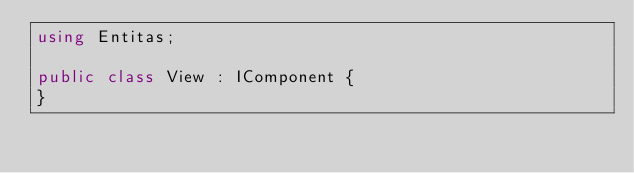Convert code to text. <code><loc_0><loc_0><loc_500><loc_500><_C#_>using Entitas;

public class View : IComponent {
}
</code> 